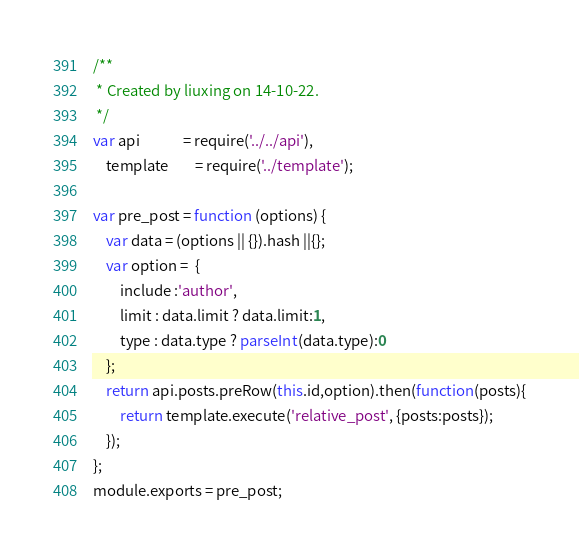Convert code to text. <code><loc_0><loc_0><loc_500><loc_500><_JavaScript_>/**
 * Created by liuxing on 14-10-22.
 */
var api             = require('../../api'),
    template        = require('../template');

var pre_post = function (options) {
    var data = (options || {}).hash ||{};
    var option =  {
        include :'author',
        limit : data.limit ? data.limit:1,
        type : data.type ? parseInt(data.type):0
    };
    return api.posts.preRow(this.id,option).then(function(posts){
        return template.execute('relative_post', {posts:posts});
    });
};
module.exports = pre_post;</code> 